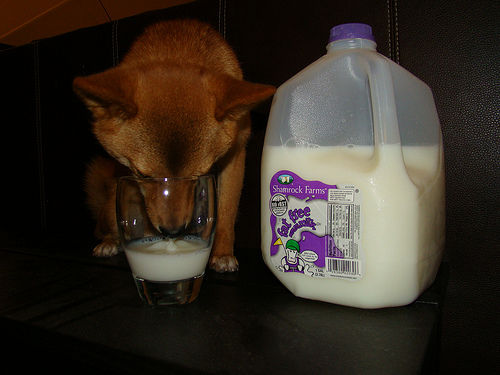<image>
Is the dog to the right of the milk? No. The dog is not to the right of the milk. The horizontal positioning shows a different relationship. 